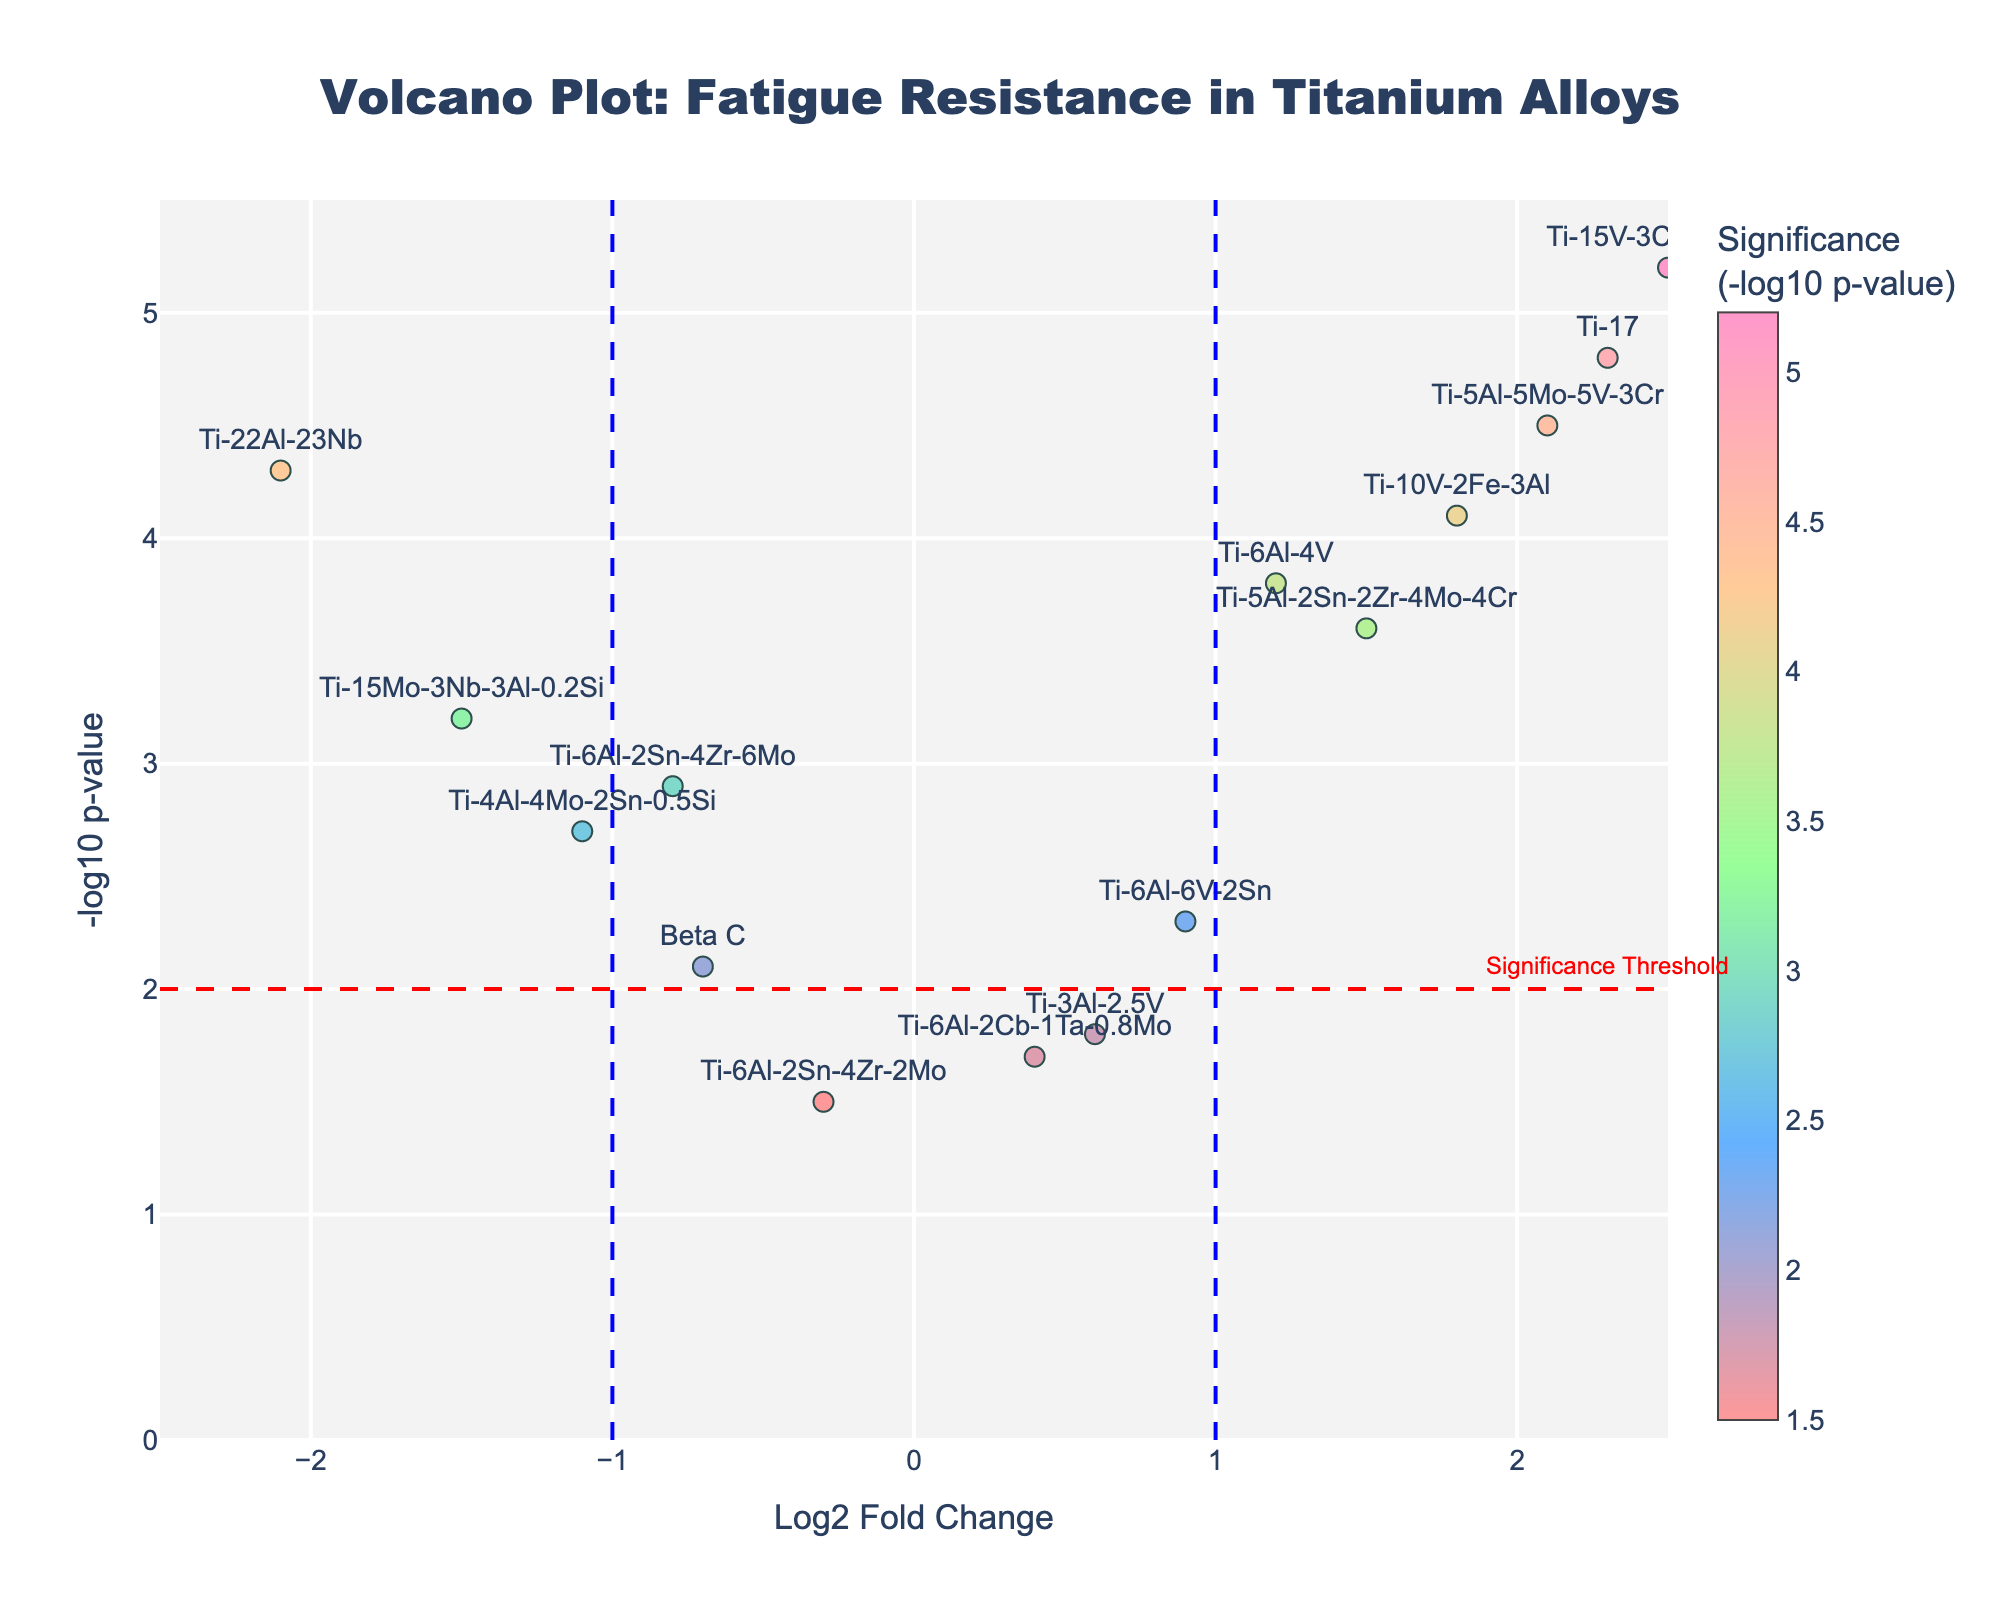What is the color of the markers that represent significance? The color gradient represents the Negative Log10 PValue, with varying shades indicating different levels of significance.
Answer: Varying shades, including reds, blues, and greens What are the axis titles of the plot? The x-axis title is "Log2 Fold Change" and the y-axis title is "-log10 p-value," as indicated on the plot.
Answer: Log2 Fold Change, -log10 p-value How many materials have a positive log2 fold change? From the scatter plot, count the markers to the right of the y-axis (positive Log2 Fold Change).
Answer: 6 materials What is the significance threshold in the figure? A red dashed line at y = 2 indicates the significance threshold.
Answer: -log10 p-value = 2 Which material has the highest significance value (-log10 p-value)? The material at the highest point on the y-axis is Ti-15V-3Cr-3Sn-3Al.
Answer: Ti-15V-3Cr-3Sn-3Al Which material has the smallest log2 fold change? Look for the material furthest to the left on the x-axis. It is Ti-22Al-23Nb with a fold change of -2.1.
Answer: Ti-22Al-23Nb What does the blue dashed line on the x-axis represent? The blue dashed lines on the x-axis represent the fold change thresholds at -1 and 1.
Answer: Fold change thresholds Which material shows both high log2 fold change and high significance? Ti-17 is positioned towards the top right, indicating both high Log2 Fold Change (2.3) and high -log10 p-value (4.8).
Answer: Ti-17 What can be inferred about the fatigue resistance of Ti-6Al-2Sn-4Zr-6Mo? Ti-6Al-2Sn-4Zr-6Mo has a negative log2 fold change and moderate negative log10 p-value, indicating it might have lower fatigue resistance and moderate significance.
Answer: Lower fatigue resistance, moderate significance How many materials fall above the significance threshold? Count the number of data points above the red dashed line (y = 2). There are 8 materials above this line.
Answer: 8 materials 